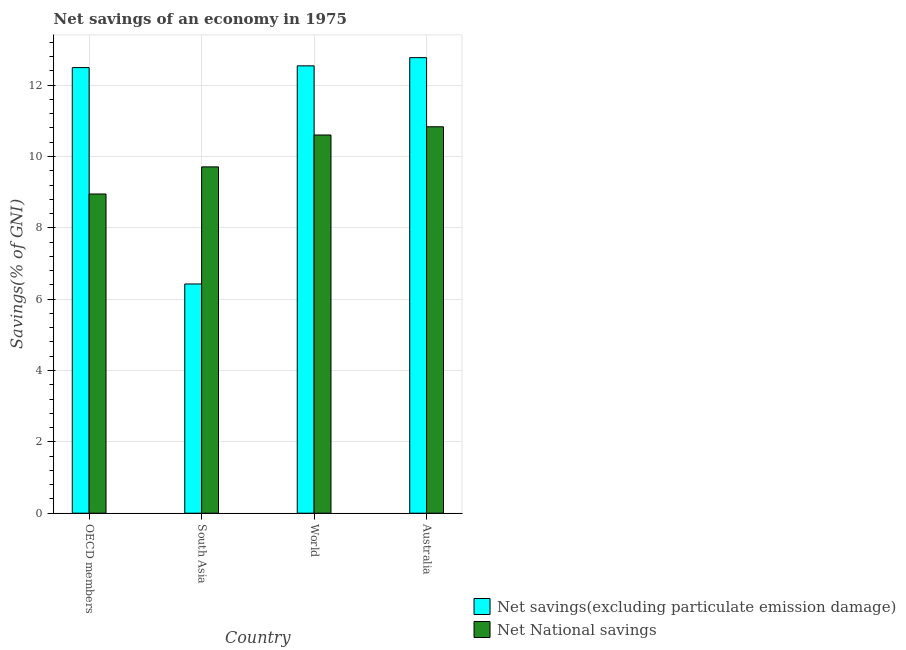How many groups of bars are there?
Ensure brevity in your answer.  4. What is the net national savings in South Asia?
Your response must be concise. 9.71. Across all countries, what is the maximum net savings(excluding particulate emission damage)?
Keep it short and to the point. 12.77. Across all countries, what is the minimum net savings(excluding particulate emission damage)?
Your answer should be compact. 6.43. In which country was the net savings(excluding particulate emission damage) maximum?
Provide a short and direct response. Australia. What is the total net national savings in the graph?
Make the answer very short. 40.09. What is the difference between the net national savings in South Asia and that in World?
Your response must be concise. -0.89. What is the difference between the net savings(excluding particulate emission damage) in Australia and the net national savings in OECD members?
Make the answer very short. 3.82. What is the average net national savings per country?
Provide a succinct answer. 10.02. What is the difference between the net savings(excluding particulate emission damage) and net national savings in South Asia?
Offer a very short reply. -3.28. In how many countries, is the net savings(excluding particulate emission damage) greater than 12 %?
Ensure brevity in your answer.  3. What is the ratio of the net savings(excluding particulate emission damage) in OECD members to that in South Asia?
Provide a short and direct response. 1.94. What is the difference between the highest and the second highest net national savings?
Ensure brevity in your answer.  0.23. What is the difference between the highest and the lowest net savings(excluding particulate emission damage)?
Give a very brief answer. 6.34. In how many countries, is the net savings(excluding particulate emission damage) greater than the average net savings(excluding particulate emission damage) taken over all countries?
Your answer should be very brief. 3. What does the 1st bar from the left in South Asia represents?
Offer a very short reply. Net savings(excluding particulate emission damage). What does the 2nd bar from the right in Australia represents?
Ensure brevity in your answer.  Net savings(excluding particulate emission damage). How many bars are there?
Offer a very short reply. 8. Are all the bars in the graph horizontal?
Offer a terse response. No. How many countries are there in the graph?
Ensure brevity in your answer.  4. What is the difference between two consecutive major ticks on the Y-axis?
Offer a very short reply. 2. Are the values on the major ticks of Y-axis written in scientific E-notation?
Your answer should be very brief. No. Does the graph contain any zero values?
Your answer should be compact. No. How are the legend labels stacked?
Your response must be concise. Vertical. What is the title of the graph?
Offer a very short reply. Net savings of an economy in 1975. What is the label or title of the X-axis?
Your answer should be very brief. Country. What is the label or title of the Y-axis?
Provide a short and direct response. Savings(% of GNI). What is the Savings(% of GNI) in Net savings(excluding particulate emission damage) in OECD members?
Ensure brevity in your answer.  12.49. What is the Savings(% of GNI) of Net National savings in OECD members?
Your answer should be very brief. 8.95. What is the Savings(% of GNI) in Net savings(excluding particulate emission damage) in South Asia?
Provide a succinct answer. 6.43. What is the Savings(% of GNI) in Net National savings in South Asia?
Your response must be concise. 9.71. What is the Savings(% of GNI) in Net savings(excluding particulate emission damage) in World?
Your response must be concise. 12.54. What is the Savings(% of GNI) of Net National savings in World?
Make the answer very short. 10.6. What is the Savings(% of GNI) in Net savings(excluding particulate emission damage) in Australia?
Make the answer very short. 12.77. What is the Savings(% of GNI) of Net National savings in Australia?
Your answer should be compact. 10.83. Across all countries, what is the maximum Savings(% of GNI) in Net savings(excluding particulate emission damage)?
Make the answer very short. 12.77. Across all countries, what is the maximum Savings(% of GNI) of Net National savings?
Offer a very short reply. 10.83. Across all countries, what is the minimum Savings(% of GNI) in Net savings(excluding particulate emission damage)?
Offer a very short reply. 6.43. Across all countries, what is the minimum Savings(% of GNI) of Net National savings?
Your answer should be compact. 8.95. What is the total Savings(% of GNI) of Net savings(excluding particulate emission damage) in the graph?
Ensure brevity in your answer.  44.23. What is the total Savings(% of GNI) of Net National savings in the graph?
Give a very brief answer. 40.09. What is the difference between the Savings(% of GNI) in Net savings(excluding particulate emission damage) in OECD members and that in South Asia?
Your response must be concise. 6.07. What is the difference between the Savings(% of GNI) in Net National savings in OECD members and that in South Asia?
Your response must be concise. -0.76. What is the difference between the Savings(% of GNI) in Net savings(excluding particulate emission damage) in OECD members and that in World?
Provide a succinct answer. -0.05. What is the difference between the Savings(% of GNI) of Net National savings in OECD members and that in World?
Offer a very short reply. -1.65. What is the difference between the Savings(% of GNI) of Net savings(excluding particulate emission damage) in OECD members and that in Australia?
Your answer should be very brief. -0.28. What is the difference between the Savings(% of GNI) of Net National savings in OECD members and that in Australia?
Provide a short and direct response. -1.88. What is the difference between the Savings(% of GNI) of Net savings(excluding particulate emission damage) in South Asia and that in World?
Ensure brevity in your answer.  -6.12. What is the difference between the Savings(% of GNI) in Net National savings in South Asia and that in World?
Provide a short and direct response. -0.89. What is the difference between the Savings(% of GNI) of Net savings(excluding particulate emission damage) in South Asia and that in Australia?
Your answer should be compact. -6.34. What is the difference between the Savings(% of GNI) of Net National savings in South Asia and that in Australia?
Make the answer very short. -1.12. What is the difference between the Savings(% of GNI) of Net savings(excluding particulate emission damage) in World and that in Australia?
Keep it short and to the point. -0.23. What is the difference between the Savings(% of GNI) in Net National savings in World and that in Australia?
Your answer should be very brief. -0.23. What is the difference between the Savings(% of GNI) of Net savings(excluding particulate emission damage) in OECD members and the Savings(% of GNI) of Net National savings in South Asia?
Your response must be concise. 2.78. What is the difference between the Savings(% of GNI) in Net savings(excluding particulate emission damage) in OECD members and the Savings(% of GNI) in Net National savings in World?
Offer a very short reply. 1.89. What is the difference between the Savings(% of GNI) of Net savings(excluding particulate emission damage) in OECD members and the Savings(% of GNI) of Net National savings in Australia?
Provide a short and direct response. 1.66. What is the difference between the Savings(% of GNI) in Net savings(excluding particulate emission damage) in South Asia and the Savings(% of GNI) in Net National savings in World?
Give a very brief answer. -4.18. What is the difference between the Savings(% of GNI) in Net savings(excluding particulate emission damage) in South Asia and the Savings(% of GNI) in Net National savings in Australia?
Your response must be concise. -4.41. What is the difference between the Savings(% of GNI) in Net savings(excluding particulate emission damage) in World and the Savings(% of GNI) in Net National savings in Australia?
Give a very brief answer. 1.71. What is the average Savings(% of GNI) in Net savings(excluding particulate emission damage) per country?
Offer a terse response. 11.06. What is the average Savings(% of GNI) in Net National savings per country?
Ensure brevity in your answer.  10.02. What is the difference between the Savings(% of GNI) of Net savings(excluding particulate emission damage) and Savings(% of GNI) of Net National savings in OECD members?
Make the answer very short. 3.54. What is the difference between the Savings(% of GNI) of Net savings(excluding particulate emission damage) and Savings(% of GNI) of Net National savings in South Asia?
Provide a short and direct response. -3.28. What is the difference between the Savings(% of GNI) of Net savings(excluding particulate emission damage) and Savings(% of GNI) of Net National savings in World?
Offer a very short reply. 1.94. What is the difference between the Savings(% of GNI) in Net savings(excluding particulate emission damage) and Savings(% of GNI) in Net National savings in Australia?
Ensure brevity in your answer.  1.94. What is the ratio of the Savings(% of GNI) of Net savings(excluding particulate emission damage) in OECD members to that in South Asia?
Provide a short and direct response. 1.94. What is the ratio of the Savings(% of GNI) of Net National savings in OECD members to that in South Asia?
Offer a very short reply. 0.92. What is the ratio of the Savings(% of GNI) in Net savings(excluding particulate emission damage) in OECD members to that in World?
Your answer should be very brief. 1. What is the ratio of the Savings(% of GNI) in Net National savings in OECD members to that in World?
Ensure brevity in your answer.  0.84. What is the ratio of the Savings(% of GNI) in Net savings(excluding particulate emission damage) in OECD members to that in Australia?
Provide a short and direct response. 0.98. What is the ratio of the Savings(% of GNI) of Net National savings in OECD members to that in Australia?
Provide a succinct answer. 0.83. What is the ratio of the Savings(% of GNI) of Net savings(excluding particulate emission damage) in South Asia to that in World?
Offer a very short reply. 0.51. What is the ratio of the Savings(% of GNI) of Net National savings in South Asia to that in World?
Your answer should be compact. 0.92. What is the ratio of the Savings(% of GNI) in Net savings(excluding particulate emission damage) in South Asia to that in Australia?
Your answer should be compact. 0.5. What is the ratio of the Savings(% of GNI) in Net National savings in South Asia to that in Australia?
Offer a terse response. 0.9. What is the ratio of the Savings(% of GNI) in Net National savings in World to that in Australia?
Your answer should be compact. 0.98. What is the difference between the highest and the second highest Savings(% of GNI) in Net savings(excluding particulate emission damage)?
Offer a terse response. 0.23. What is the difference between the highest and the second highest Savings(% of GNI) of Net National savings?
Ensure brevity in your answer.  0.23. What is the difference between the highest and the lowest Savings(% of GNI) of Net savings(excluding particulate emission damage)?
Your answer should be very brief. 6.34. What is the difference between the highest and the lowest Savings(% of GNI) in Net National savings?
Make the answer very short. 1.88. 